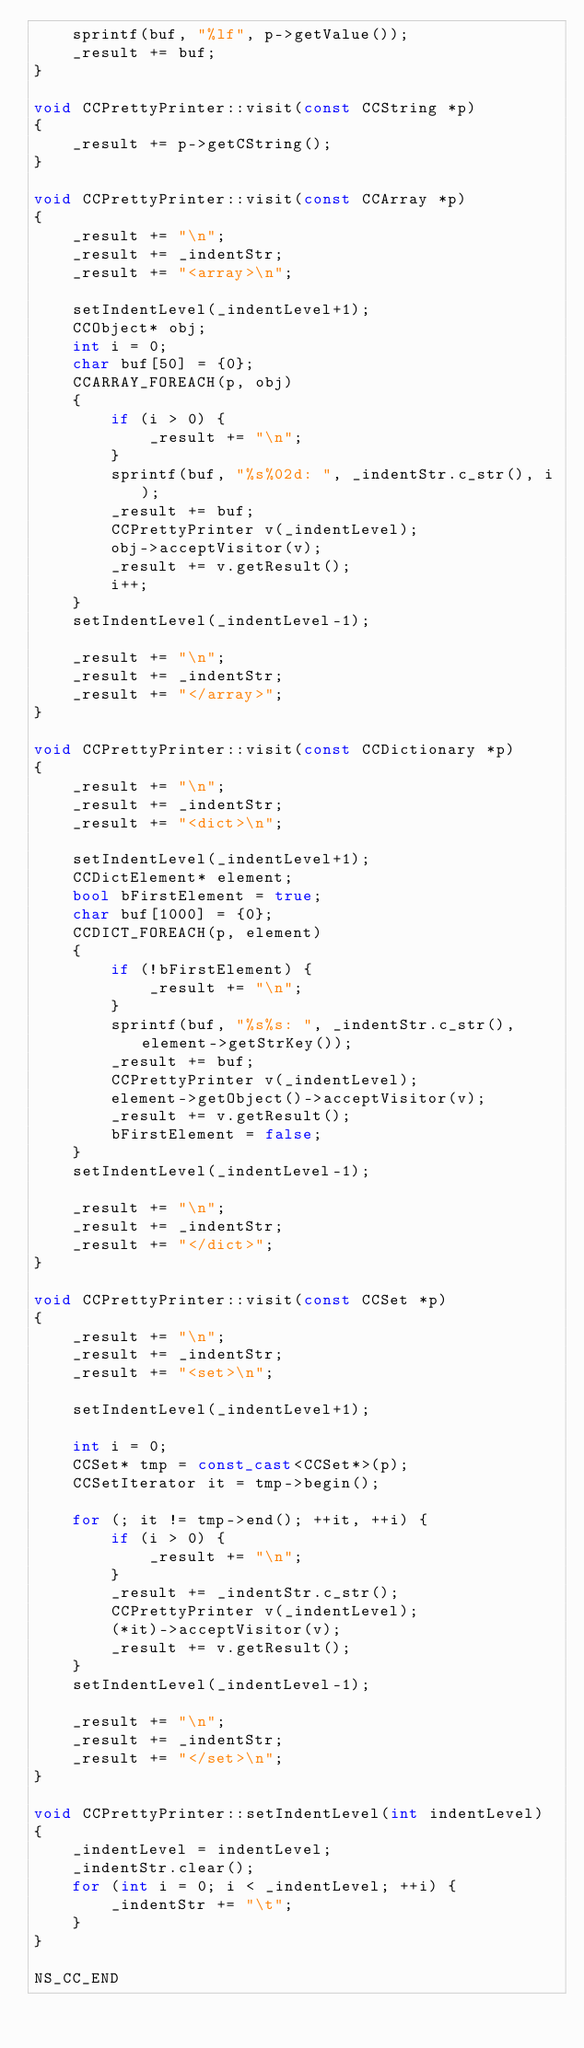<code> <loc_0><loc_0><loc_500><loc_500><_C++_>    sprintf(buf, "%lf", p->getValue());
    _result += buf;
}

void CCPrettyPrinter::visit(const CCString *p)
{
    _result += p->getCString();
}

void CCPrettyPrinter::visit(const CCArray *p)
{
    _result += "\n";
    _result += _indentStr;
    _result += "<array>\n";

    setIndentLevel(_indentLevel+1);
    CCObject* obj;
    int i = 0;
    char buf[50] = {0};
    CCARRAY_FOREACH(p, obj)
    {
        if (i > 0) {
            _result += "\n";
        }
        sprintf(buf, "%s%02d: ", _indentStr.c_str(), i);
        _result += buf;
        CCPrettyPrinter v(_indentLevel);
        obj->acceptVisitor(v);
        _result += v.getResult();
        i++;
    }
    setIndentLevel(_indentLevel-1);
    
    _result += "\n";
    _result += _indentStr;
    _result += "</array>";
}

void CCPrettyPrinter::visit(const CCDictionary *p)
{
    _result += "\n";
    _result += _indentStr;
    _result += "<dict>\n";
    
    setIndentLevel(_indentLevel+1);
    CCDictElement* element;
    bool bFirstElement = true;
    char buf[1000] = {0};
    CCDICT_FOREACH(p, element)
    {
        if (!bFirstElement) {
            _result += "\n";
        }
        sprintf(buf, "%s%s: ", _indentStr.c_str(),element->getStrKey());
        _result += buf;
        CCPrettyPrinter v(_indentLevel);
        element->getObject()->acceptVisitor(v);
        _result += v.getResult();
        bFirstElement = false;
    }
    setIndentLevel(_indentLevel-1);
    
    _result += "\n";
    _result += _indentStr;
    _result += "</dict>";
}

void CCPrettyPrinter::visit(const CCSet *p)
{
    _result += "\n";
    _result += _indentStr;
    _result += "<set>\n";
    
    setIndentLevel(_indentLevel+1);

    int i = 0;
    CCSet* tmp = const_cast<CCSet*>(p);
    CCSetIterator it = tmp->begin();

    for (; it != tmp->end(); ++it, ++i) {
        if (i > 0) {
            _result += "\n";
        }
        _result += _indentStr.c_str();
        CCPrettyPrinter v(_indentLevel);
        (*it)->acceptVisitor(v);
        _result += v.getResult();
    }
    setIndentLevel(_indentLevel-1);
    
    _result += "\n";
    _result += _indentStr;
    _result += "</set>\n";
}

void CCPrettyPrinter::setIndentLevel(int indentLevel)
{
    _indentLevel = indentLevel;
    _indentStr.clear();
    for (int i = 0; i < _indentLevel; ++i) {
        _indentStr += "\t";
    }
}

NS_CC_END
</code> 